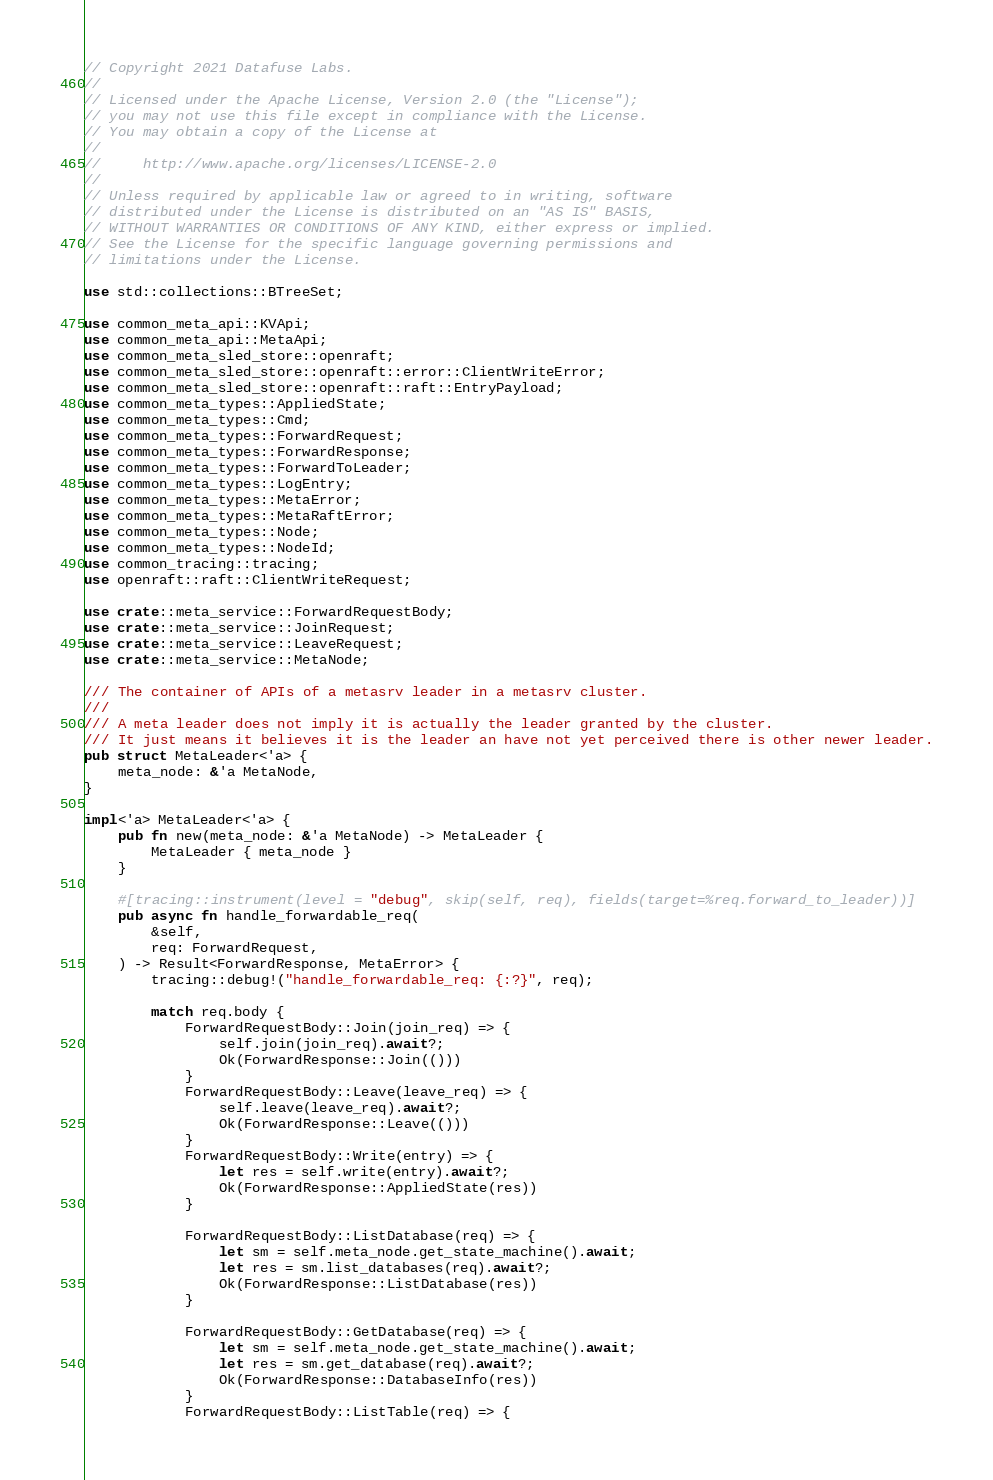<code> <loc_0><loc_0><loc_500><loc_500><_Rust_>// Copyright 2021 Datafuse Labs.
//
// Licensed under the Apache License, Version 2.0 (the "License");
// you may not use this file except in compliance with the License.
// You may obtain a copy of the License at
//
//     http://www.apache.org/licenses/LICENSE-2.0
//
// Unless required by applicable law or agreed to in writing, software
// distributed under the License is distributed on an "AS IS" BASIS,
// WITHOUT WARRANTIES OR CONDITIONS OF ANY KIND, either express or implied.
// See the License for the specific language governing permissions and
// limitations under the License.

use std::collections::BTreeSet;

use common_meta_api::KVApi;
use common_meta_api::MetaApi;
use common_meta_sled_store::openraft;
use common_meta_sled_store::openraft::error::ClientWriteError;
use common_meta_sled_store::openraft::raft::EntryPayload;
use common_meta_types::AppliedState;
use common_meta_types::Cmd;
use common_meta_types::ForwardRequest;
use common_meta_types::ForwardResponse;
use common_meta_types::ForwardToLeader;
use common_meta_types::LogEntry;
use common_meta_types::MetaError;
use common_meta_types::MetaRaftError;
use common_meta_types::Node;
use common_meta_types::NodeId;
use common_tracing::tracing;
use openraft::raft::ClientWriteRequest;

use crate::meta_service::ForwardRequestBody;
use crate::meta_service::JoinRequest;
use crate::meta_service::LeaveRequest;
use crate::meta_service::MetaNode;

/// The container of APIs of a metasrv leader in a metasrv cluster.
///
/// A meta leader does not imply it is actually the leader granted by the cluster.
/// It just means it believes it is the leader an have not yet perceived there is other newer leader.
pub struct MetaLeader<'a> {
    meta_node: &'a MetaNode,
}

impl<'a> MetaLeader<'a> {
    pub fn new(meta_node: &'a MetaNode) -> MetaLeader {
        MetaLeader { meta_node }
    }

    #[tracing::instrument(level = "debug", skip(self, req), fields(target=%req.forward_to_leader))]
    pub async fn handle_forwardable_req(
        &self,
        req: ForwardRequest,
    ) -> Result<ForwardResponse, MetaError> {
        tracing::debug!("handle_forwardable_req: {:?}", req);

        match req.body {
            ForwardRequestBody::Join(join_req) => {
                self.join(join_req).await?;
                Ok(ForwardResponse::Join(()))
            }
            ForwardRequestBody::Leave(leave_req) => {
                self.leave(leave_req).await?;
                Ok(ForwardResponse::Leave(()))
            }
            ForwardRequestBody::Write(entry) => {
                let res = self.write(entry).await?;
                Ok(ForwardResponse::AppliedState(res))
            }

            ForwardRequestBody::ListDatabase(req) => {
                let sm = self.meta_node.get_state_machine().await;
                let res = sm.list_databases(req).await?;
                Ok(ForwardResponse::ListDatabase(res))
            }

            ForwardRequestBody::GetDatabase(req) => {
                let sm = self.meta_node.get_state_machine().await;
                let res = sm.get_database(req).await?;
                Ok(ForwardResponse::DatabaseInfo(res))
            }
            ForwardRequestBody::ListTable(req) => {</code> 